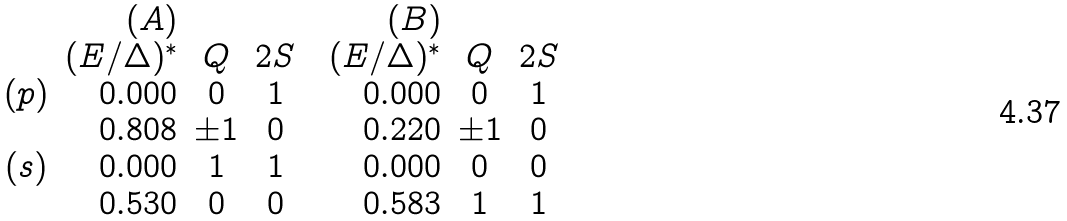Convert formula to latex. <formula><loc_0><loc_0><loc_500><loc_500>\begin{array} { c r c c c r c c } & ( A ) & & & & ( B ) & & \\ & ( E / \Delta ) ^ { * } & Q & 2 S & & ( E / \Delta ) ^ { * } & Q & 2 S \\ ( p ) & 0 . 0 0 0 & 0 & 1 & & 0 . 0 0 0 & 0 & 1 \\ & 0 . 8 0 8 & \pm 1 & 0 & & 0 . 2 2 0 & \pm 1 & 0 \\ ( s ) & 0 . 0 0 0 & 1 & 1 & & 0 . 0 0 0 & 0 & 0 \\ & 0 . 5 3 0 & 0 & 0 & & 0 . 5 8 3 & 1 & 1 \\ \end{array}</formula> 